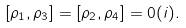Convert formula to latex. <formula><loc_0><loc_0><loc_500><loc_500>[ \rho _ { 1 } , \rho _ { 3 } ] = [ \rho _ { 2 } , \rho _ { 4 } ] = 0 ( i ) .</formula> 